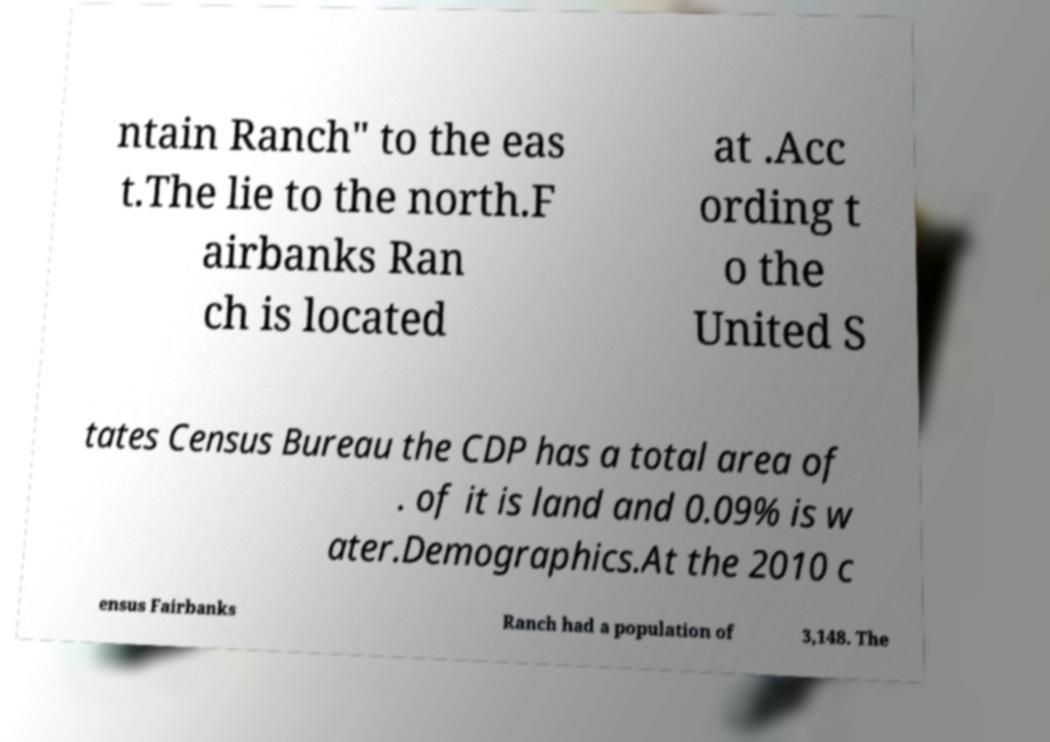For documentation purposes, I need the text within this image transcribed. Could you provide that? ntain Ranch" to the eas t.The lie to the north.F airbanks Ran ch is located at .Acc ording t o the United S tates Census Bureau the CDP has a total area of . of it is land and 0.09% is w ater.Demographics.At the 2010 c ensus Fairbanks Ranch had a population of 3,148. The 